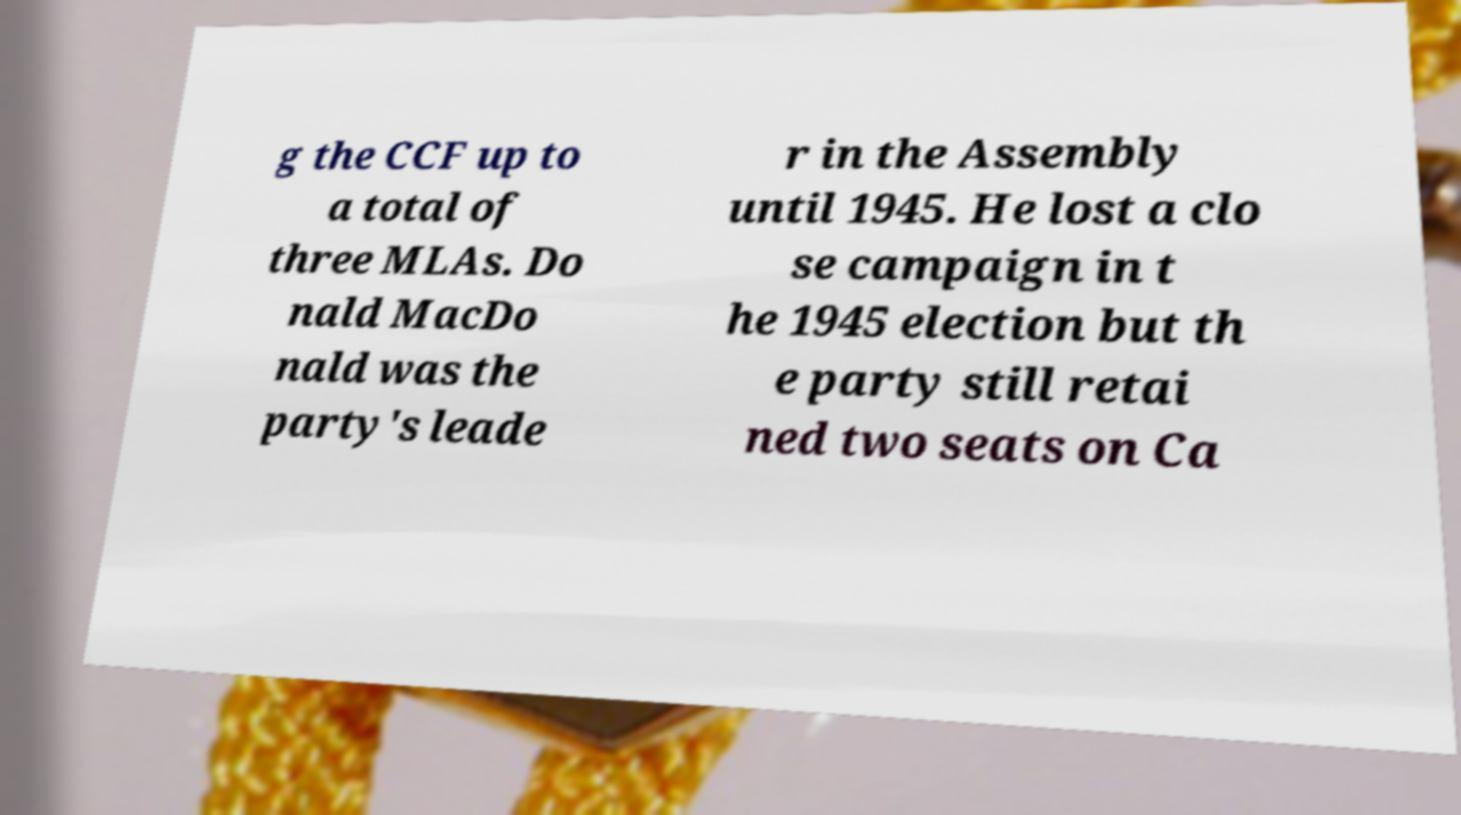There's text embedded in this image that I need extracted. Can you transcribe it verbatim? g the CCF up to a total of three MLAs. Do nald MacDo nald was the party's leade r in the Assembly until 1945. He lost a clo se campaign in t he 1945 election but th e party still retai ned two seats on Ca 